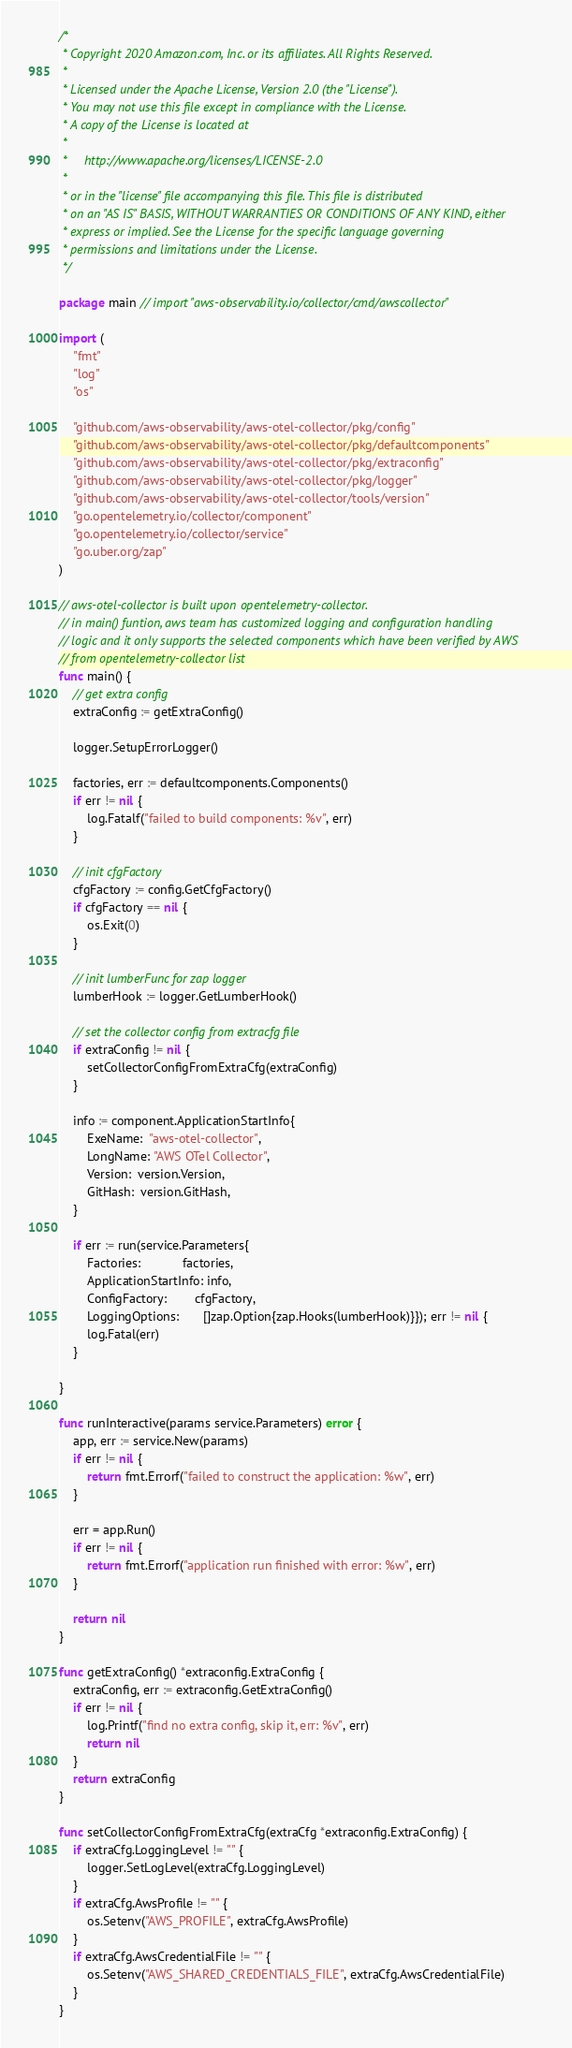<code> <loc_0><loc_0><loc_500><loc_500><_Go_>/*
 * Copyright 2020 Amazon.com, Inc. or its affiliates. All Rights Reserved.
 *
 * Licensed under the Apache License, Version 2.0 (the "License").
 * You may not use this file except in compliance with the License.
 * A copy of the License is located at
 *
 *     http://www.apache.org/licenses/LICENSE-2.0
 *
 * or in the "license" file accompanying this file. This file is distributed
 * on an "AS IS" BASIS, WITHOUT WARRANTIES OR CONDITIONS OF ANY KIND, either
 * express or implied. See the License for the specific language governing
 * permissions and limitations under the License.
 */

package main // import "aws-observability.io/collector/cmd/awscollector"

import (
	"fmt"
	"log"
	"os"

	"github.com/aws-observability/aws-otel-collector/pkg/config"
	"github.com/aws-observability/aws-otel-collector/pkg/defaultcomponents"
	"github.com/aws-observability/aws-otel-collector/pkg/extraconfig"
	"github.com/aws-observability/aws-otel-collector/pkg/logger"
	"github.com/aws-observability/aws-otel-collector/tools/version"
	"go.opentelemetry.io/collector/component"
	"go.opentelemetry.io/collector/service"
	"go.uber.org/zap"
)

// aws-otel-collector is built upon opentelemetry-collector.
// in main() funtion, aws team has customized logging and configuration handling
// logic and it only supports the selected components which have been verified by AWS
// from opentelemetry-collector list
func main() {
	// get extra config
	extraConfig := getExtraConfig()

	logger.SetupErrorLogger()

	factories, err := defaultcomponents.Components()
	if err != nil {
		log.Fatalf("failed to build components: %v", err)
	}

	// init cfgFactory
	cfgFactory := config.GetCfgFactory()
	if cfgFactory == nil {
		os.Exit(0)
	}

	// init lumberFunc for zap logger
	lumberHook := logger.GetLumberHook()

	// set the collector config from extracfg file
	if extraConfig != nil {
		setCollectorConfigFromExtraCfg(extraConfig)
	}

	info := component.ApplicationStartInfo{
		ExeName:  "aws-otel-collector",
		LongName: "AWS OTel Collector",
		Version:  version.Version,
		GitHash:  version.GitHash,
	}

	if err := run(service.Parameters{
		Factories:            factories,
		ApplicationStartInfo: info,
		ConfigFactory:        cfgFactory,
		LoggingOptions:       []zap.Option{zap.Hooks(lumberHook)}}); err != nil {
		log.Fatal(err)
	}

}

func runInteractive(params service.Parameters) error {
	app, err := service.New(params)
	if err != nil {
		return fmt.Errorf("failed to construct the application: %w", err)
	}

	err = app.Run()
	if err != nil {
		return fmt.Errorf("application run finished with error: %w", err)
	}

	return nil
}

func getExtraConfig() *extraconfig.ExtraConfig {
	extraConfig, err := extraconfig.GetExtraConfig()
	if err != nil {
		log.Printf("find no extra config, skip it, err: %v", err)
		return nil
	}
	return extraConfig
}

func setCollectorConfigFromExtraCfg(extraCfg *extraconfig.ExtraConfig) {
	if extraCfg.LoggingLevel != "" {
		logger.SetLogLevel(extraCfg.LoggingLevel)
	}
	if extraCfg.AwsProfile != "" {
		os.Setenv("AWS_PROFILE", extraCfg.AwsProfile)
	}
	if extraCfg.AwsCredentialFile != "" {
		os.Setenv("AWS_SHARED_CREDENTIALS_FILE", extraCfg.AwsCredentialFile)
	}
}
</code> 